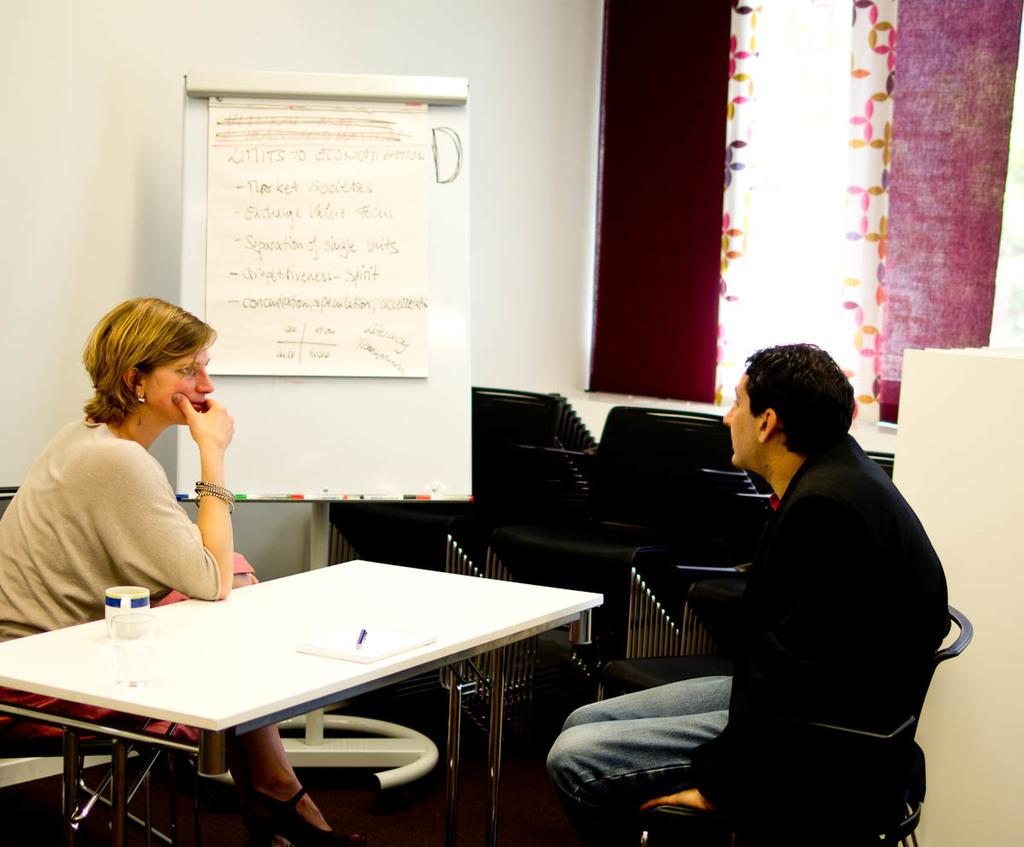How many people are in the image? There are two persons in the image. What are the persons doing in the image? The persons are sitting on chairs. Where are the chairs located in relation to the table? The chairs are around a table. What can be found on the table? There are objects on the table. What can be seen in the background of the image? There is a board, a wall, and a curtain visible in the background. What type of day is depicted in the image? The provided facts do not mention any specific day or time of day, so it cannot be determined from the image. Can you describe the aftermath of the event in the image? There is no event or any indication of an event taking place in the image, so it cannot be described. 